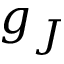<formula> <loc_0><loc_0><loc_500><loc_500>g _ { J }</formula> 